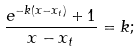Convert formula to latex. <formula><loc_0><loc_0><loc_500><loc_500>\frac { e ^ { - k ( x - x _ { t } ) } + 1 } { x - x _ { t } } = k ;</formula> 